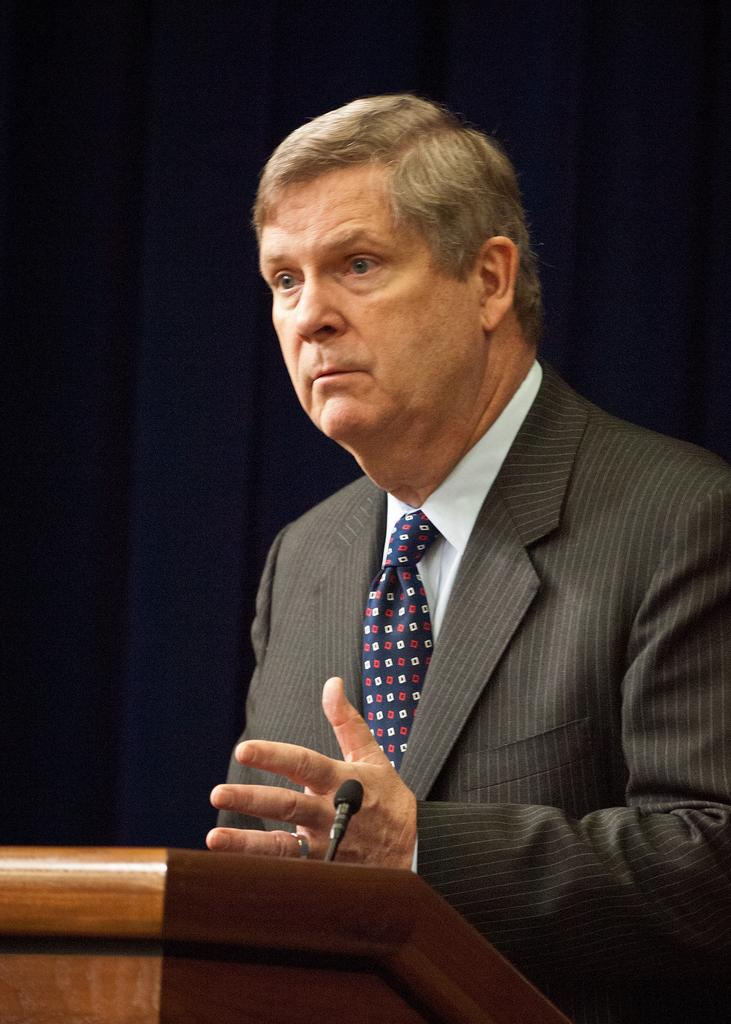What is the main subject of the image? There is a man standing in the center of the image. What is the man standing in front of? There is a podium in front of the man. What is on the podium? A microphone is placed on the podium. What can be seen in the background of the image? There is a curtain visible in the background of the image. What time of day is it in the image, and how can you tell? The time of day cannot be determined from the image, as there are no clues or indicators of the time. 